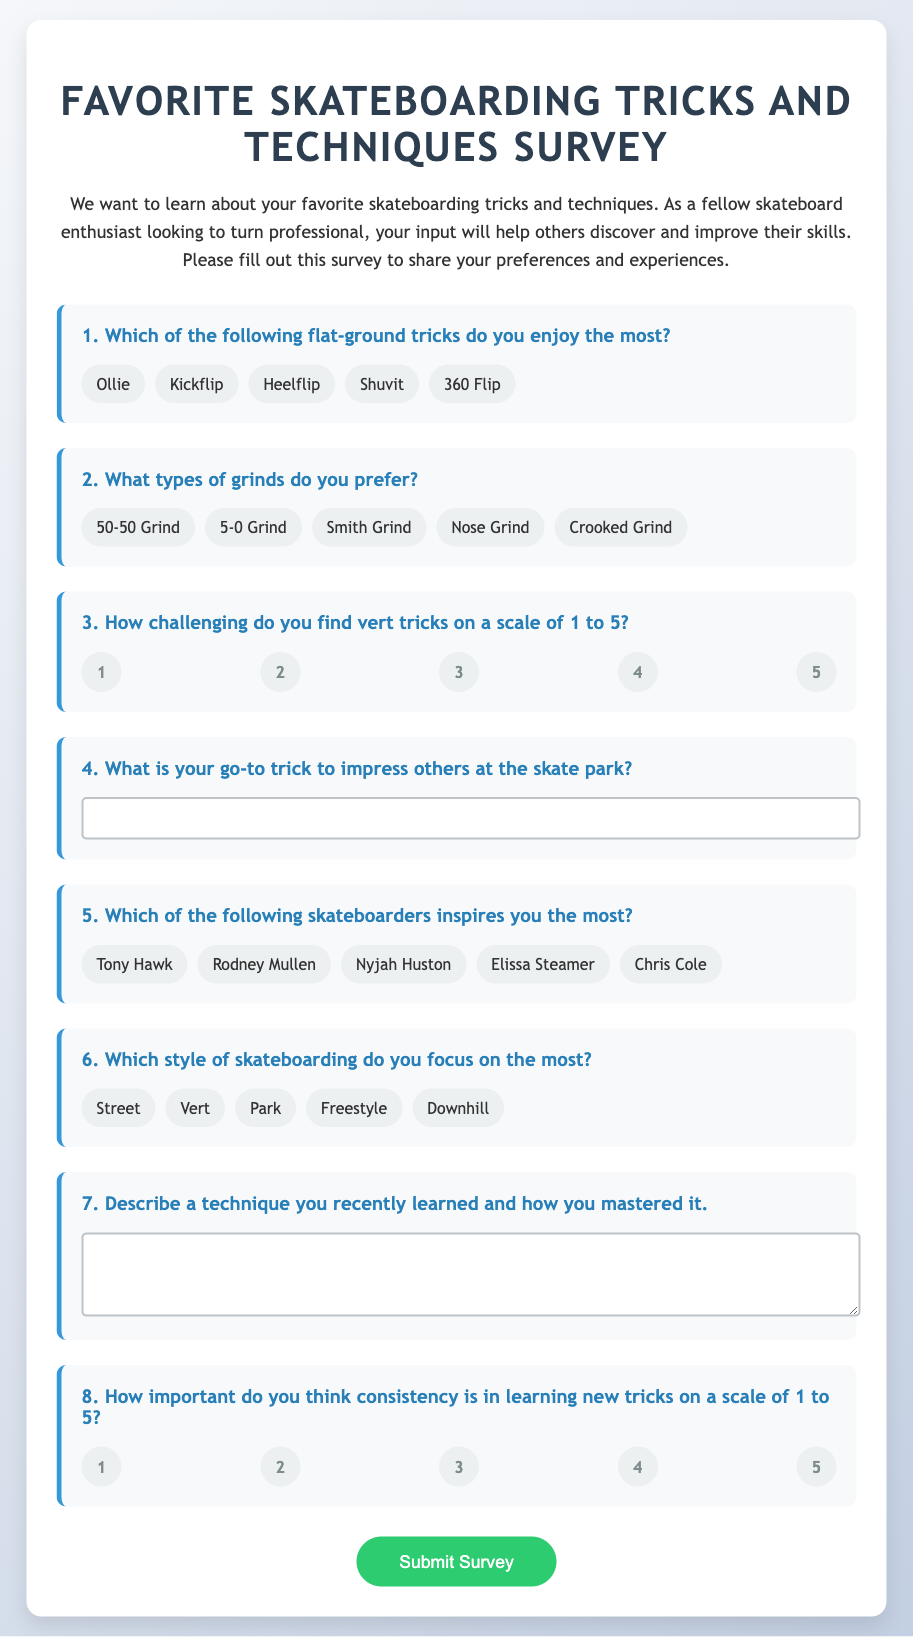What is the title of the survey? The title of the survey is presented in the header of the document.
Answer: Favorite Skateboarding Tricks and Techniques Survey How many categories of tricks are listed in the first question? The first question encompasses several categories of tricks, and the number can be counted from the document.
Answer: 5 What is the highest rating possible for the challenge of vert tricks? The rating scale in the document shows the maximum value for this question.
Answer: 5 Who are the skateboarders listed as inspirations in the fifth question? The fifth question includes names of skateboarders from the options presented in the survey.
Answer: Tony Hawk, Rodney Mullen, Nyjah Huston, Elissa Steamer, Chris Cole What type of skateboarder style is NOT mentioned in the sixth question? The options for the style of skateboarding can be assessed to find out which style is omitted.
Answer: None (all styles listed) How many open-ended questions are there in the survey? Open-ended questions allow respondents to provide their answers in a free format, which can be counted from the document.
Answer: 2 